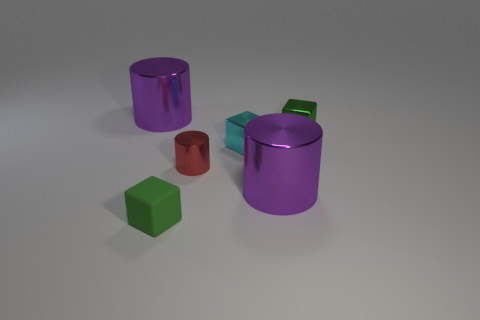What is the shape of the green thing that is in front of the large shiny cylinder that is right of the metal object that is left of the green matte thing?
Your answer should be very brief. Cube. There is a large cylinder right of the green rubber object; does it have the same color as the big object that is left of the small red cylinder?
Provide a short and direct response. Yes. Is there anything else that has the same size as the green matte cube?
Give a very brief answer. Yes. Are there any large metal objects left of the small red metallic object?
Provide a short and direct response. Yes. How many tiny red metal things have the same shape as the matte thing?
Your response must be concise. 0. What is the color of the big cylinder that is right of the big purple object left of the purple metal object in front of the cyan shiny object?
Your answer should be very brief. Purple. Does the tiny green cube left of the tiny green shiny thing have the same material as the green object that is behind the red shiny thing?
Your response must be concise. No. What number of things are tiny green blocks that are in front of the green metal cube or tiny cylinders?
Give a very brief answer. 2. How many objects are either large cyan metal balls or large objects to the right of the red shiny object?
Offer a very short reply. 1. What number of blocks have the same size as the cyan shiny object?
Provide a succinct answer. 2. 